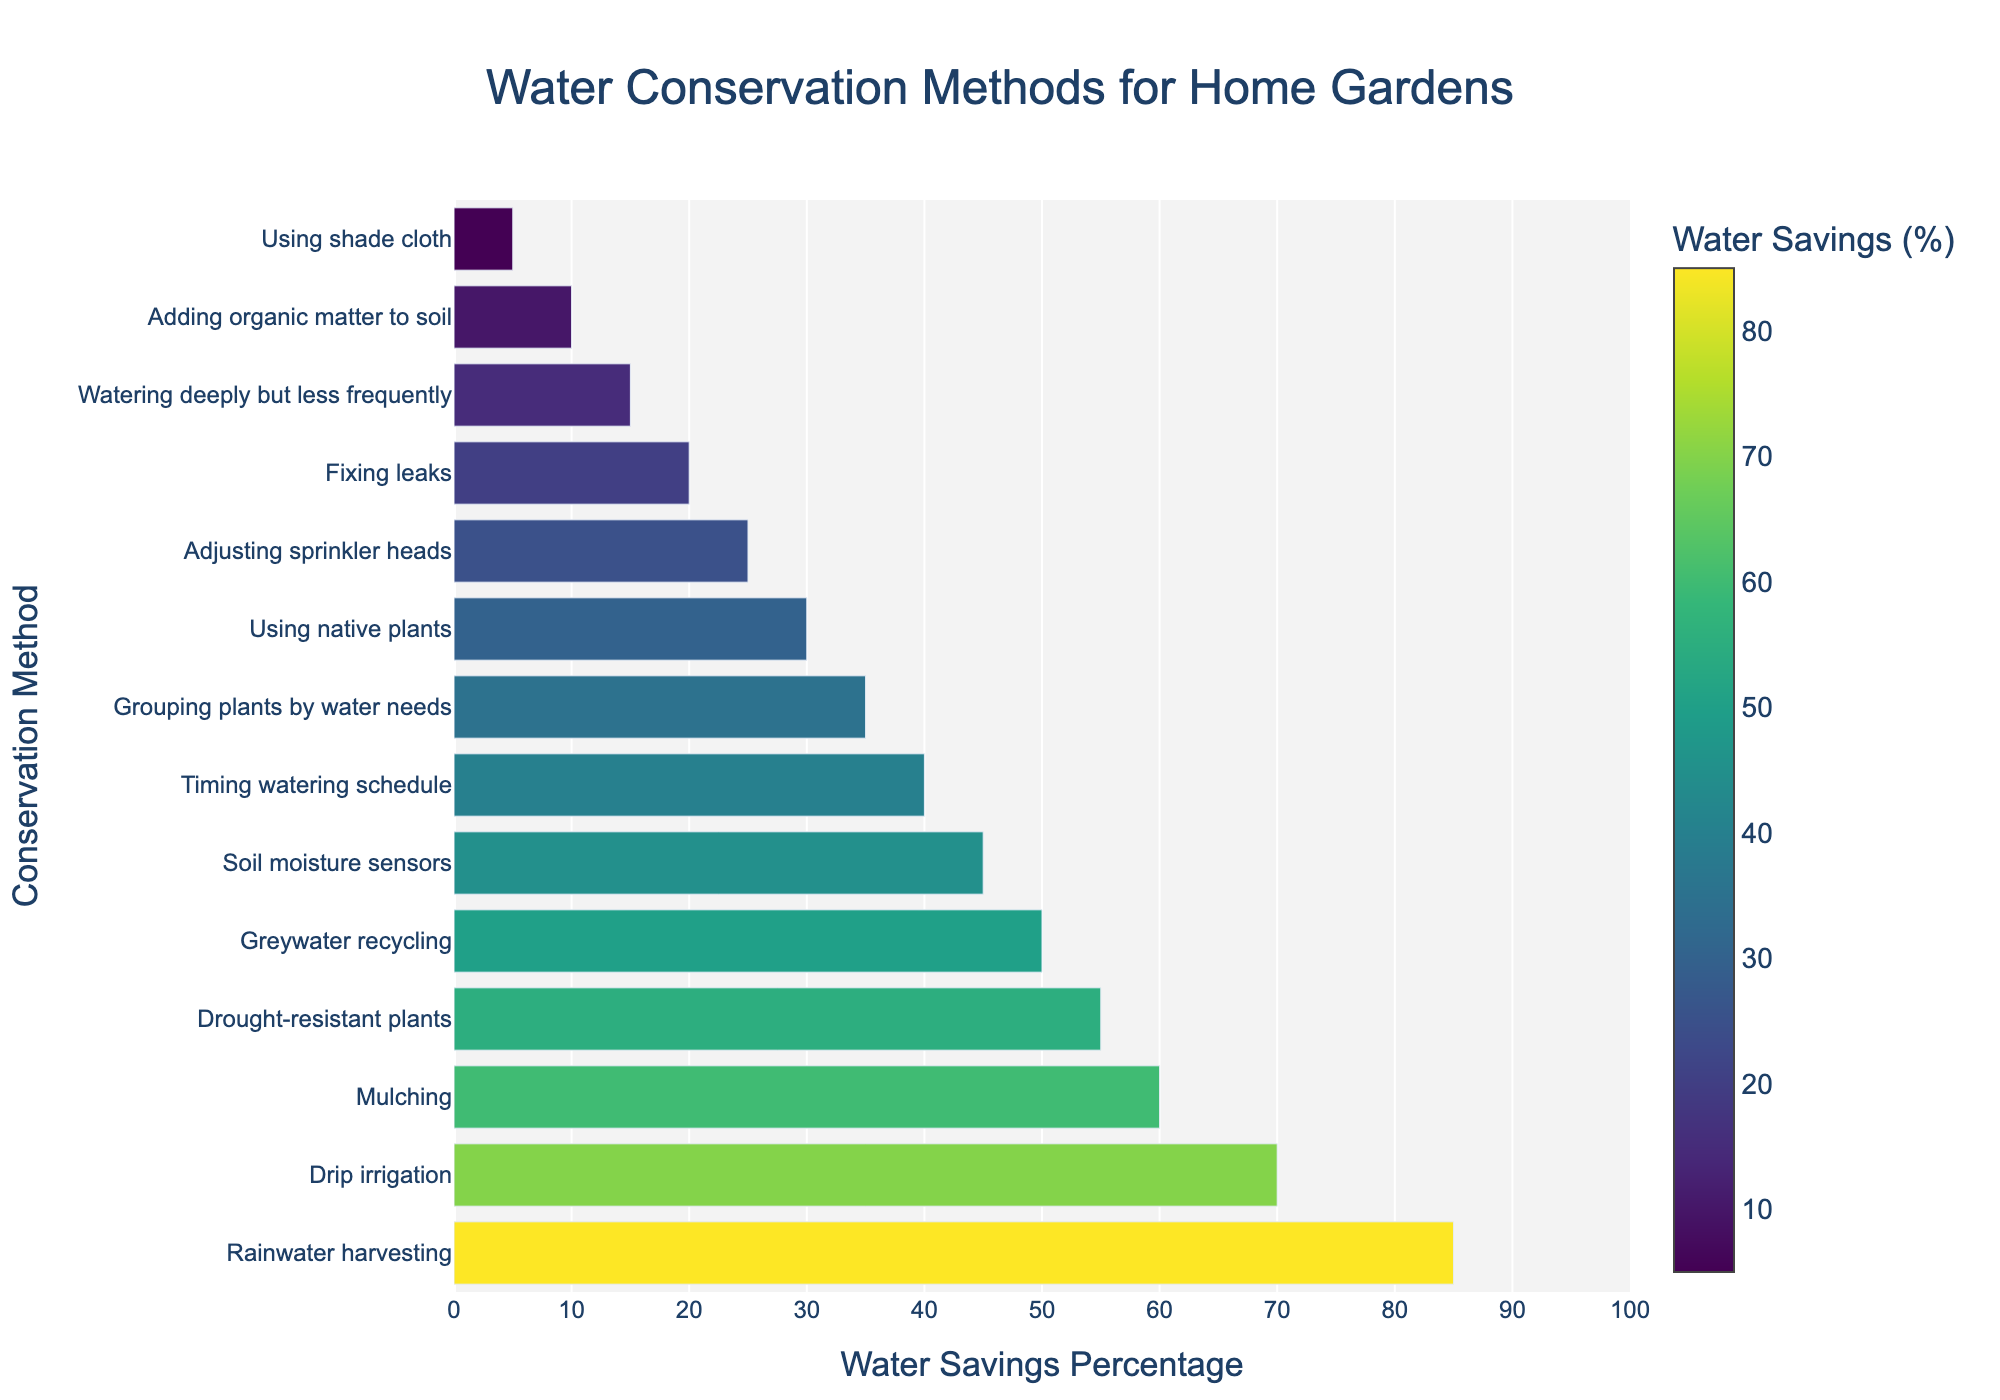What's the most efficient water conservation method for home gardens? The biggest bar on the chart represents the most efficient method. The bar for "Rainwater harvesting" is the longest and yields the highest water savings percentage at 85%.
Answer: Rainwater harvesting How much more efficient is drip irrigation compared to using native plants? The chart shows that drip irrigation has a water savings percentage of 70%, while using native plants has a percentage of 30%. Subtract the latter from the former: 70% - 30% = 40%.
Answer: 40% Which method is positioned exactly halfway between the top and bottom in terms of water savings percentage? There are 14 methods listed, so the 7th method from the top (starting from the highest efficiency) will be the median. "Grouping plants by water needs" is the 7th method with a water savings percentage of 35%.
Answer: Grouping plants by water needs What's the combined efficiency of adjusting sprinkler heads and fixing leaks? The water savings percentage for adjusting sprinkler heads is 25%, and for fixing leaks, it's 20%. Adding these percentages gives: 25% + 20% = 45%.
Answer: 45% Is adding organic matter to soil more or less efficient than using shade cloth? Comparing their respective water savings percentages, adding organic matter to soil has 10%, and using shade cloth has 5%. 10% is greater than 5%, so adding organic matter to soil is more efficient.
Answer: More efficient Determine the method that saves half as much water as drought-resistant plants. Drought-resistant plants save 55% water. Find half of this: 55% / 2 = 27.5%. The closest method to 27.5% in the chart is using native plants, which saves 30%.
Answer: Using native plants How many water conservation methods have an efficiency score above 50%? Count the bars in the chart with water savings percentages exceeding 50%. These are: Rainwater harvesting (85%), Drip irrigation (70%), Mulching (60%), and Drought-resistant plants (55%). That's four methods.
Answer: 4 Which method has almost double the efficiency of adding organic matter to the soil? Adding organic matter to soil has an efficiency of 10%. Double this efficiency is 20%. The closest method to 20% is fixing leaks, which has an exactly equal efficiency percentage.
Answer: Fixing leaks What's the visual representation of the least efficient water-saving method? The least efficient method will have the shortest bar. The shortest bar on the chart corresponds to "Using shade cloth", which has a water savings percentage of 5%.
Answer: Using shade cloth 